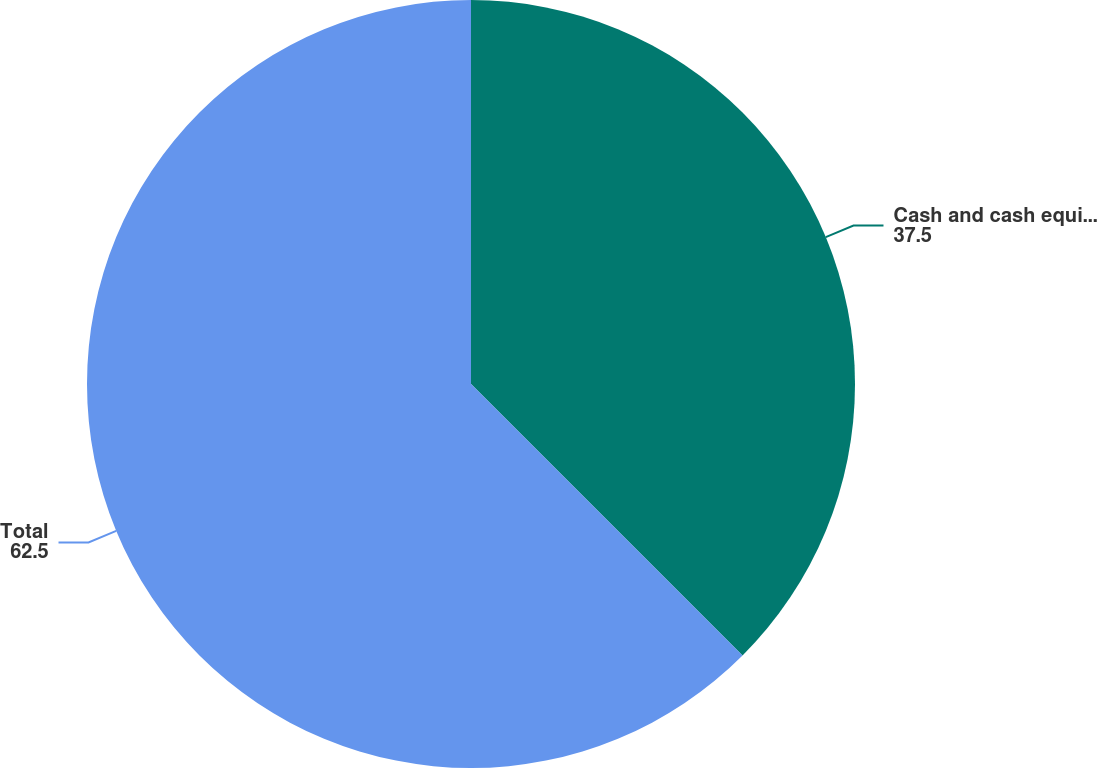Convert chart to OTSL. <chart><loc_0><loc_0><loc_500><loc_500><pie_chart><fcel>Cash and cash equivalents<fcel>Total<nl><fcel>37.5%<fcel>62.5%<nl></chart> 